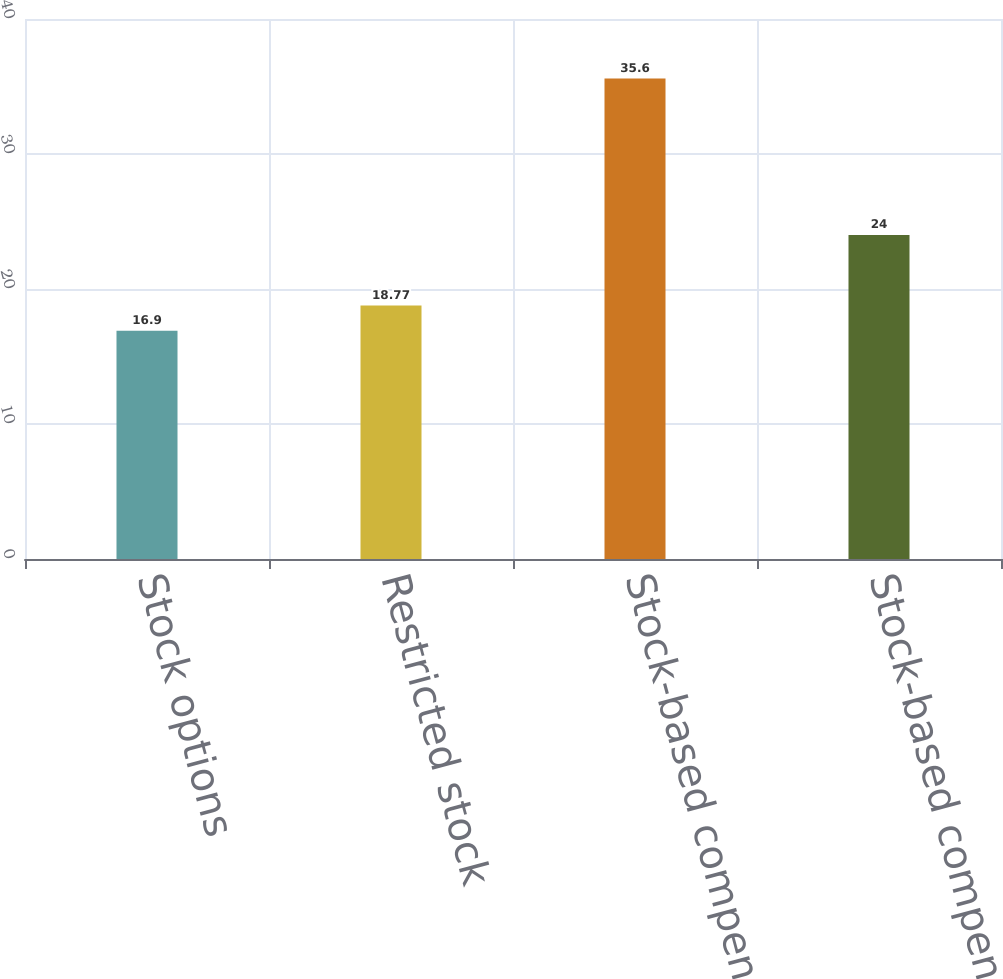Convert chart. <chart><loc_0><loc_0><loc_500><loc_500><bar_chart><fcel>Stock options<fcel>Restricted stock<fcel>Stock-based compensation<fcel>Stock-based compensation net<nl><fcel>16.9<fcel>18.77<fcel>35.6<fcel>24<nl></chart> 